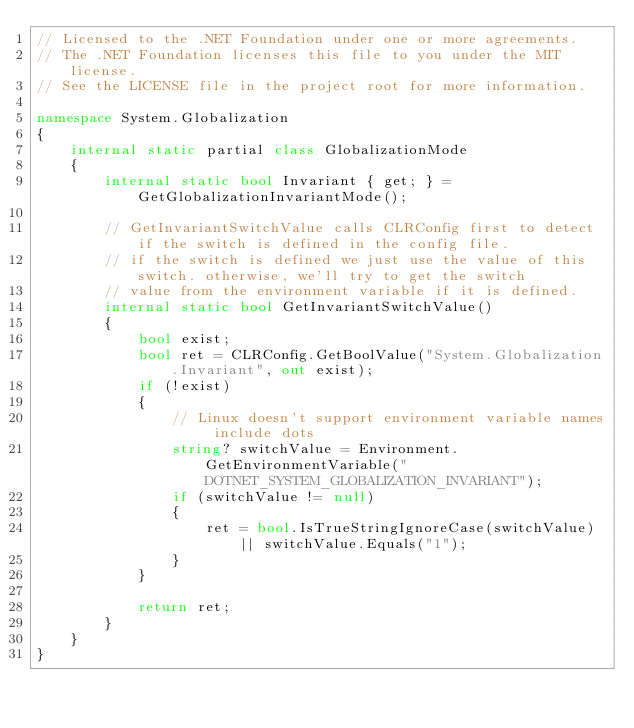<code> <loc_0><loc_0><loc_500><loc_500><_C#_>// Licensed to the .NET Foundation under one or more agreements.
// The .NET Foundation licenses this file to you under the MIT license.
// See the LICENSE file in the project root for more information.

namespace System.Globalization
{
    internal static partial class GlobalizationMode
    {
        internal static bool Invariant { get; } = GetGlobalizationInvariantMode();

        // GetInvariantSwitchValue calls CLRConfig first to detect if the switch is defined in the config file.
        // if the switch is defined we just use the value of this switch. otherwise, we'll try to get the switch
        // value from the environment variable if it is defined.
        internal static bool GetInvariantSwitchValue()
        {
            bool exist;
            bool ret = CLRConfig.GetBoolValue("System.Globalization.Invariant", out exist);
            if (!exist)
            {
                // Linux doesn't support environment variable names include dots
                string? switchValue = Environment.GetEnvironmentVariable("DOTNET_SYSTEM_GLOBALIZATION_INVARIANT");
                if (switchValue != null)
                {
                    ret = bool.IsTrueStringIgnoreCase(switchValue) || switchValue.Equals("1");
                }
            }

            return ret;
        }
    }
}
</code> 